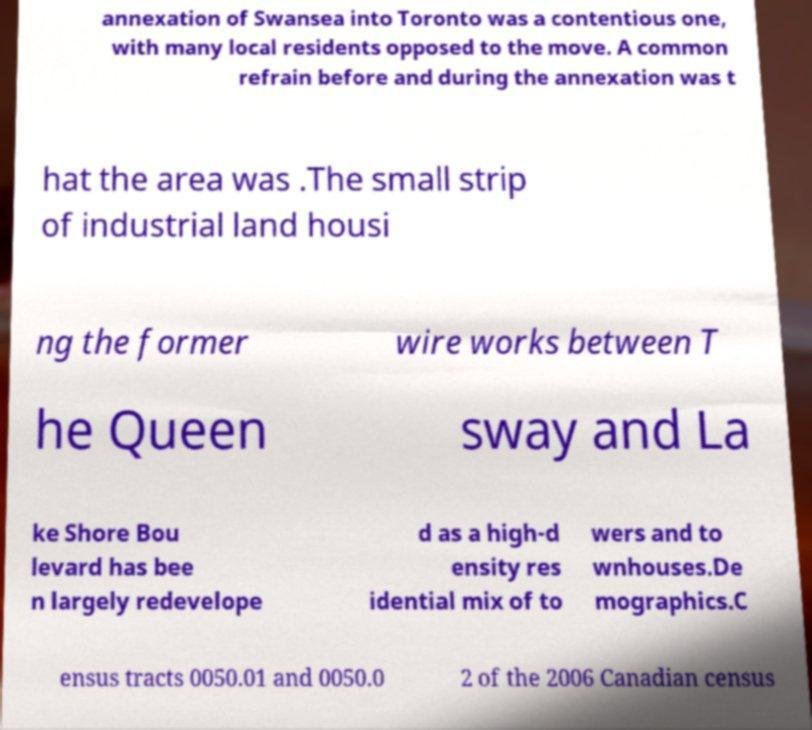Could you assist in decoding the text presented in this image and type it out clearly? annexation of Swansea into Toronto was a contentious one, with many local residents opposed to the move. A common refrain before and during the annexation was t hat the area was .The small strip of industrial land housi ng the former wire works between T he Queen sway and La ke Shore Bou levard has bee n largely redevelope d as a high-d ensity res idential mix of to wers and to wnhouses.De mographics.C ensus tracts 0050.01 and 0050.0 2 of the 2006 Canadian census 